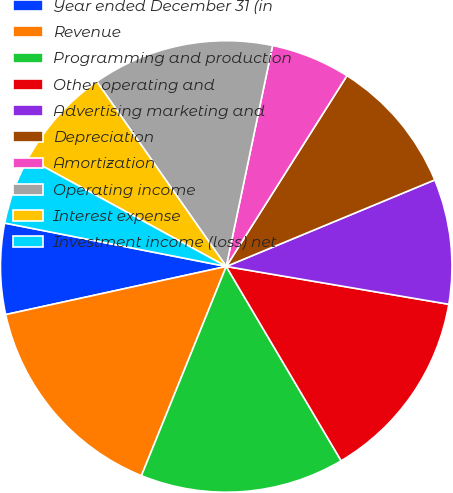<chart> <loc_0><loc_0><loc_500><loc_500><pie_chart><fcel>Year ended December 31 (in<fcel>Revenue<fcel>Programming and production<fcel>Other operating and<fcel>Advertising marketing and<fcel>Depreciation<fcel>Amortization<fcel>Operating income<fcel>Interest expense<fcel>Investment income (loss) net<nl><fcel>6.5%<fcel>15.45%<fcel>14.63%<fcel>13.82%<fcel>8.94%<fcel>9.76%<fcel>5.69%<fcel>13.01%<fcel>7.32%<fcel>4.88%<nl></chart> 